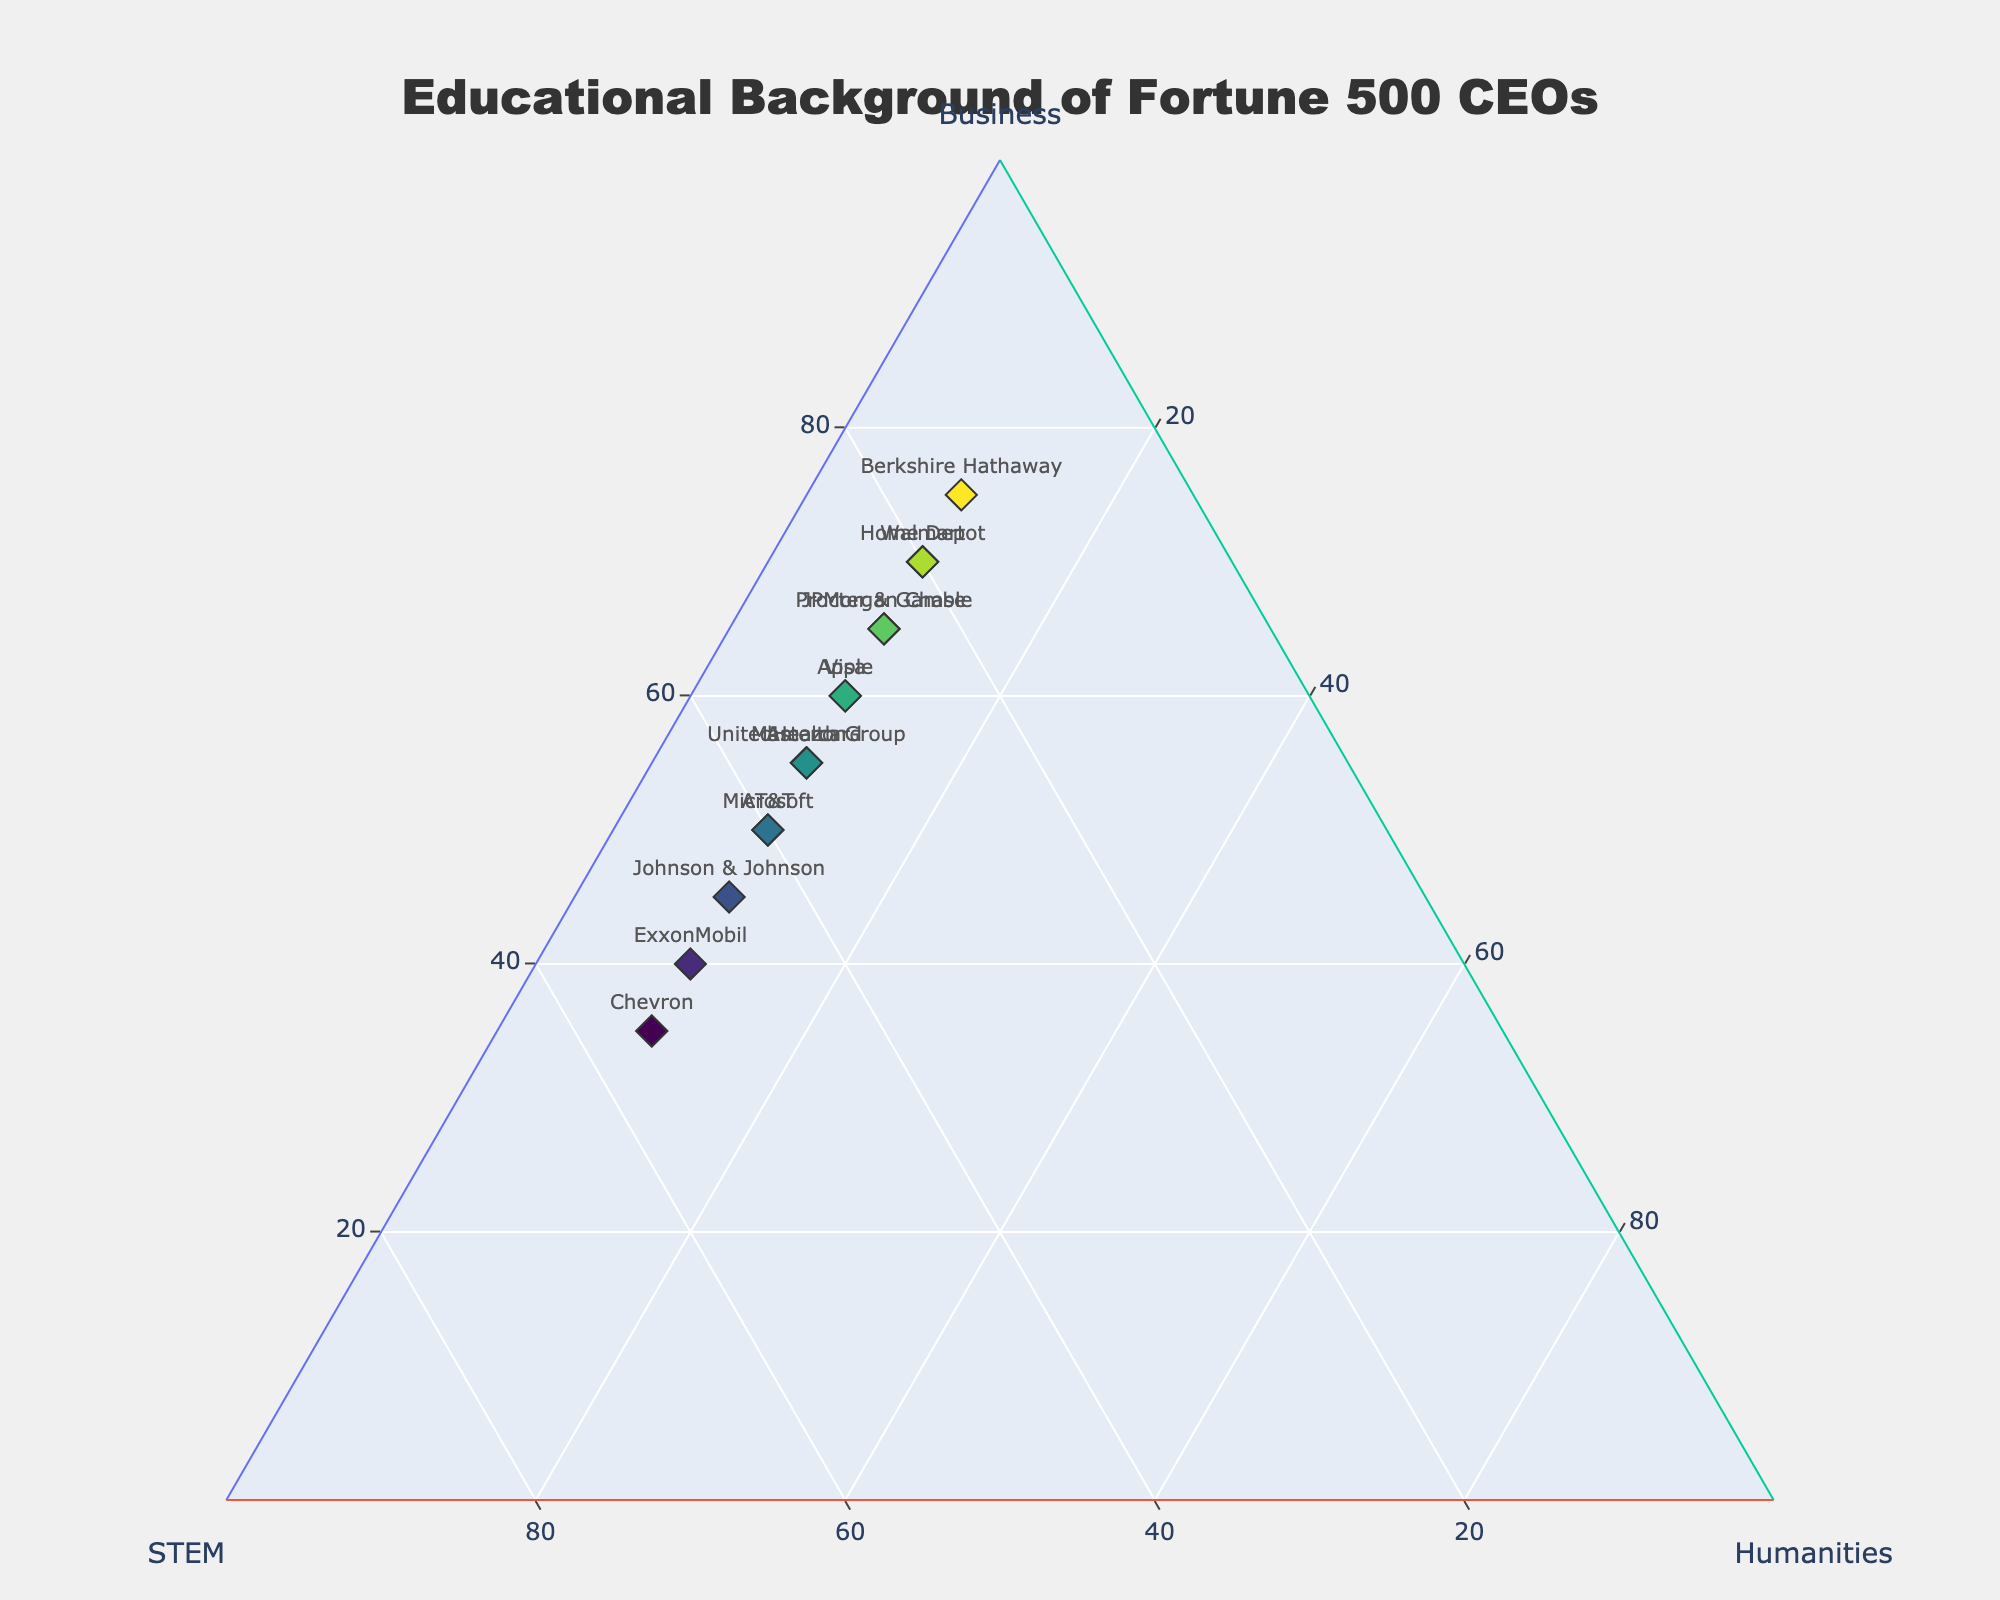What is the most common educational background for Fortune 500 CEOs on this plot? The plot shows that most CEOs have a background in Business, as the percentage for Business degrees is higher in many companies compared to STEM and Humanities.
Answer: Business Which company has the highest proportion of CEOs with STEM degrees? By comparing the positions of the markers, we see Chevron has the highest proportion of STEM degrees at 55%.
Answer: Chevron Which companies have an equal proportion of Business and STEM degrees? Companies with markers placed on the line between Business and STEM are either edge cases or equal. Johnson & Johnson and Apple are close but not equal. No companies have exactly equal proportions in the plot.
Answer: None What is the range of Humanities degrees percentages across all companies? The plot shows that the Humanities percentages are all located in the base triangle section aligned with 10%.
Answer: 0% (Note: indicates a fixed percentage, so technically no range) For companies with more diverse educational backgrounds, which shows more balanced proportions between Business, STEM, and Humanities? A more balanced company would be located more centrally within the ternary plot, for instance, Johnson & Johnson shows 45% Business, 45% STEM, and 10% Humanities which closely balances Business and STEM.
Answer: Johnson & Johnson How many companies have Business degrees as their highest percentage? By counting the markers whose a-axis (Business) value is greater than the others, there are notably Amazon, Apple, Microsoft, Berkshire Hathaway, JPMorgan Chase, Visa, Procter & Gamble, AT&T, Home Depot, and Walmart.
Answer: 10 Between Amazon and Microsoft, which company has a higher proportion of Humanities degrees? Both Amazon and Microsoft show 10% Humanities as per their c-axis value.
Answer: Equal If you average the percentage of Business degrees for all companies, what would it be? Sum up the Business percentages and divide by the number of companies (60+50+55+70+40+65+45+75+55+35+60+65+50+70+55) = 850. Then divide by 15 companies to get the average, 850/15 = 56.67%.
Answer: 56.67% Which company stands out as having the highest proportion of Business degrees? Berkshire Hathaway stands out with the highest at 75%, as noted by marker placement and comparing values visually.
Answer: Berkshire Hathaway By focusing only on STEM and Business degree comparisons, which company indicates a strong bias towards STEM over Business? Chevron stands out, having a greater proportion of STEM (55%) compared to Business (35%).
Answer: Chevron 